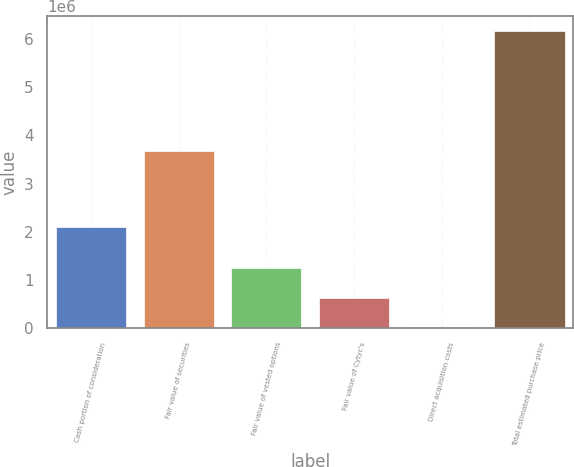Convert chart. <chart><loc_0><loc_0><loc_500><loc_500><bar_chart><fcel>Cash portion of consideration<fcel>Fair value of securities<fcel>Fair value of vested options<fcel>Fair value of Cytyc's<fcel>Direct acquisition costs<fcel>Total estimated purchase price<nl><fcel>2.0948e+06<fcel>3.6715e+06<fcel>1.25074e+06<fcel>637470<fcel>24200<fcel>6.1569e+06<nl></chart> 